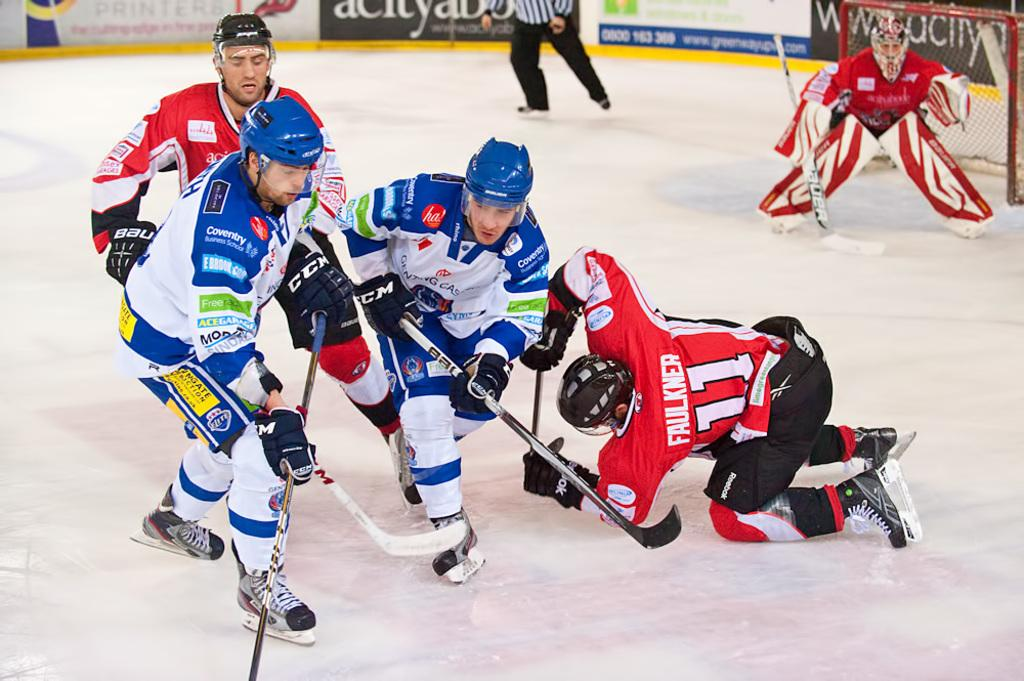<image>
Relay a brief, clear account of the picture shown. A guy named Faulkner is trying to get the ball from other team in a hockey game. 